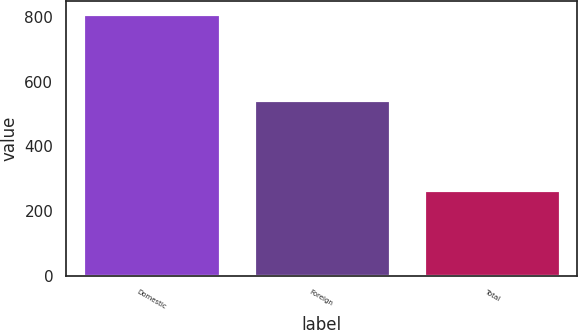Convert chart. <chart><loc_0><loc_0><loc_500><loc_500><bar_chart><fcel>Domestic<fcel>Foreign<fcel>Total<nl><fcel>808<fcel>544<fcel>264<nl></chart> 